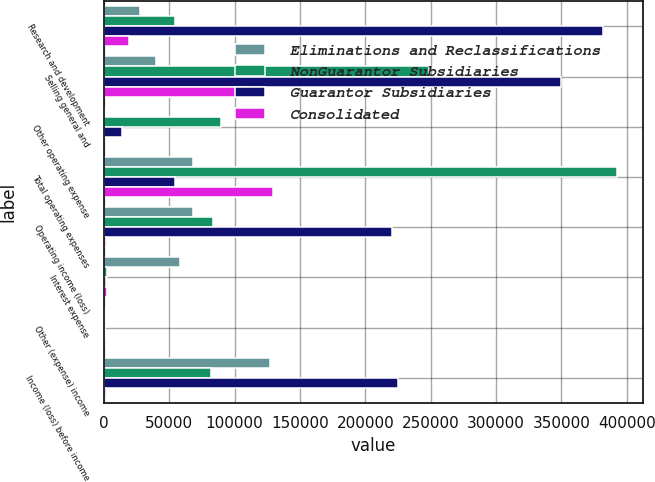Convert chart to OTSL. <chart><loc_0><loc_0><loc_500><loc_500><stacked_bar_chart><ecel><fcel>Research and development<fcel>Selling general and<fcel>Other operating expense<fcel>Total operating expenses<fcel>Operating income (loss)<fcel>Interest expense<fcel>Other (expense) income<fcel>Income (loss) before income<nl><fcel>Eliminations and Reclassifications<fcel>27688<fcel>39882<fcel>588<fcel>68158<fcel>68158<fcel>58133<fcel>929<fcel>127220<nl><fcel>NonGuarantor Subsidiaries<fcel>54663<fcel>248601<fcel>89454<fcel>392718<fcel>83431<fcel>2340<fcel>973<fcel>82102<nl><fcel>Guarantor Subsidiaries<fcel>382109<fcel>349739<fcel>13463<fcel>54663<fcel>220536<fcel>1505<fcel>642<fcel>225140<nl><fcel>Consolidated<fcel>19357<fcel>110471<fcel>325<fcel>129503<fcel>1335<fcel>2430<fcel>8<fcel>1327<nl></chart> 